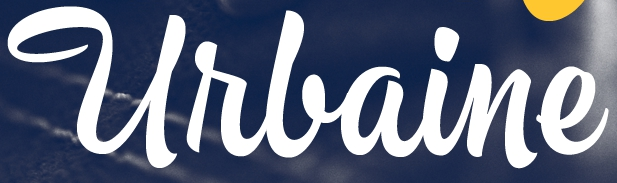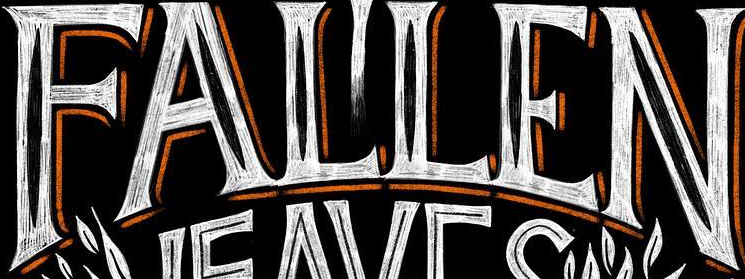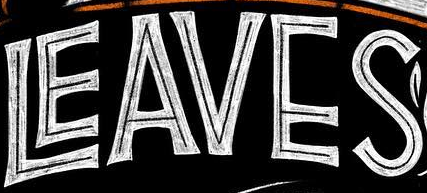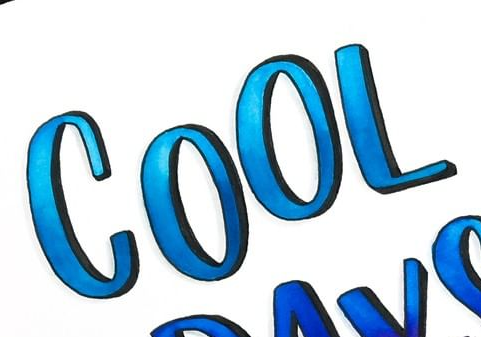What text is displayed in these images sequentially, separated by a semicolon? Urlaine; FALLEN; LEAVES; COOL 